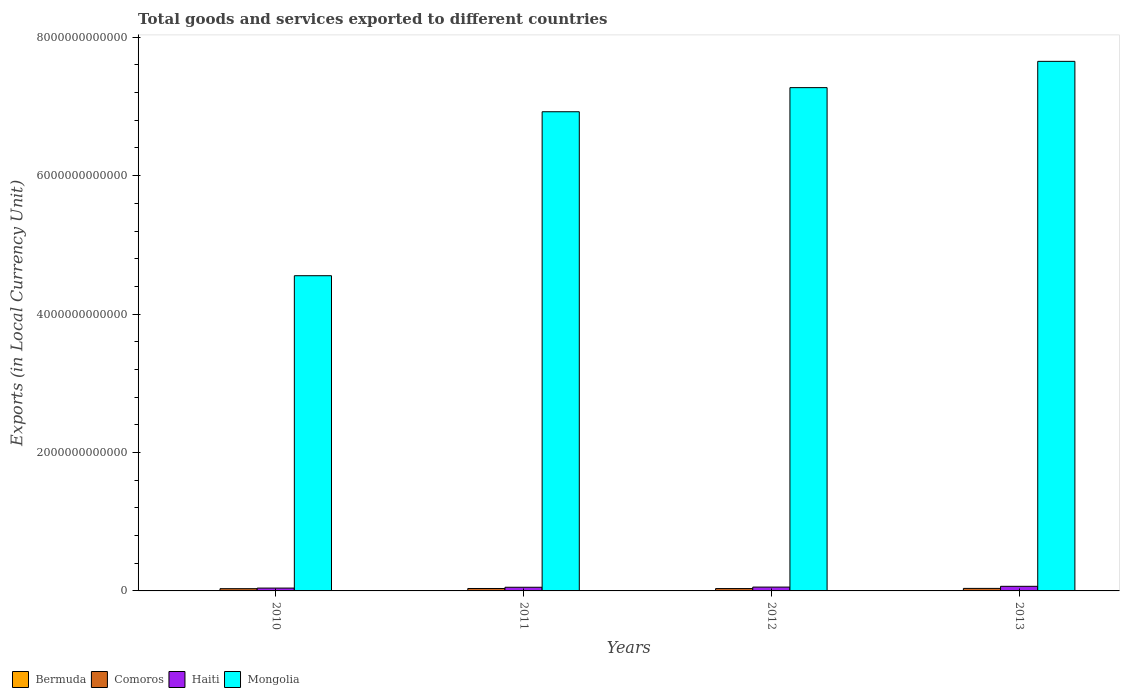How many different coloured bars are there?
Make the answer very short. 4. Are the number of bars per tick equal to the number of legend labels?
Your answer should be very brief. Yes. How many bars are there on the 1st tick from the left?
Ensure brevity in your answer.  4. What is the label of the 3rd group of bars from the left?
Make the answer very short. 2012. In how many cases, is the number of bars for a given year not equal to the number of legend labels?
Give a very brief answer. 0. What is the Amount of goods and services exports in Bermuda in 2012?
Your response must be concise. 2.59e+09. Across all years, what is the maximum Amount of goods and services exports in Comoros?
Your answer should be compact. 3.64e+1. Across all years, what is the minimum Amount of goods and services exports in Mongolia?
Your response must be concise. 4.55e+12. What is the total Amount of goods and services exports in Haiti in the graph?
Your answer should be compact. 2.16e+11. What is the difference between the Amount of goods and services exports in Mongolia in 2010 and that in 2012?
Provide a succinct answer. -2.72e+12. What is the difference between the Amount of goods and services exports in Haiti in 2012 and the Amount of goods and services exports in Comoros in 2013?
Offer a terse response. 1.91e+1. What is the average Amount of goods and services exports in Comoros per year?
Offer a terse response. 3.45e+1. In the year 2010, what is the difference between the Amount of goods and services exports in Haiti and Amount of goods and services exports in Mongolia?
Give a very brief answer. -4.51e+12. What is the ratio of the Amount of goods and services exports in Haiti in 2012 to that in 2013?
Offer a very short reply. 0.83. Is the Amount of goods and services exports in Bermuda in 2011 less than that in 2012?
Provide a short and direct response. No. What is the difference between the highest and the second highest Amount of goods and services exports in Bermuda?
Provide a succinct answer. 4.78e+07. What is the difference between the highest and the lowest Amount of goods and services exports in Mongolia?
Keep it short and to the point. 3.10e+12. Is it the case that in every year, the sum of the Amount of goods and services exports in Bermuda and Amount of goods and services exports in Haiti is greater than the sum of Amount of goods and services exports in Mongolia and Amount of goods and services exports in Comoros?
Provide a succinct answer. No. What does the 3rd bar from the left in 2012 represents?
Ensure brevity in your answer.  Haiti. What does the 1st bar from the right in 2010 represents?
Your response must be concise. Mongolia. How many bars are there?
Ensure brevity in your answer.  16. What is the difference between two consecutive major ticks on the Y-axis?
Your answer should be compact. 2.00e+12. Does the graph contain grids?
Provide a succinct answer. No. Where does the legend appear in the graph?
Your answer should be very brief. Bottom left. How many legend labels are there?
Provide a short and direct response. 4. How are the legend labels stacked?
Ensure brevity in your answer.  Horizontal. What is the title of the graph?
Offer a terse response. Total goods and services exported to different countries. What is the label or title of the X-axis?
Offer a very short reply. Years. What is the label or title of the Y-axis?
Your answer should be very brief. Exports (in Local Currency Unit). What is the Exports (in Local Currency Unit) in Bermuda in 2010?
Your response must be concise. 2.70e+09. What is the Exports (in Local Currency Unit) in Comoros in 2010?
Give a very brief answer. 3.25e+1. What is the Exports (in Local Currency Unit) in Haiti in 2010?
Keep it short and to the point. 4.10e+1. What is the Exports (in Local Currency Unit) in Mongolia in 2010?
Give a very brief answer. 4.55e+12. What is the Exports (in Local Currency Unit) in Bermuda in 2011?
Make the answer very short. 2.64e+09. What is the Exports (in Local Currency Unit) of Comoros in 2011?
Keep it short and to the point. 3.50e+1. What is the Exports (in Local Currency Unit) in Haiti in 2011?
Keep it short and to the point. 5.28e+1. What is the Exports (in Local Currency Unit) in Mongolia in 2011?
Your answer should be very brief. 6.92e+12. What is the Exports (in Local Currency Unit) of Bermuda in 2012?
Offer a terse response. 2.59e+09. What is the Exports (in Local Currency Unit) in Comoros in 2012?
Your answer should be very brief. 3.40e+1. What is the Exports (in Local Currency Unit) of Haiti in 2012?
Provide a short and direct response. 5.55e+1. What is the Exports (in Local Currency Unit) of Mongolia in 2012?
Your answer should be compact. 7.27e+12. What is the Exports (in Local Currency Unit) of Bermuda in 2013?
Your answer should be compact. 2.66e+09. What is the Exports (in Local Currency Unit) in Comoros in 2013?
Your answer should be compact. 3.64e+1. What is the Exports (in Local Currency Unit) in Haiti in 2013?
Give a very brief answer. 6.65e+1. What is the Exports (in Local Currency Unit) of Mongolia in 2013?
Your answer should be very brief. 7.65e+12. Across all years, what is the maximum Exports (in Local Currency Unit) of Bermuda?
Provide a short and direct response. 2.70e+09. Across all years, what is the maximum Exports (in Local Currency Unit) in Comoros?
Your response must be concise. 3.64e+1. Across all years, what is the maximum Exports (in Local Currency Unit) in Haiti?
Provide a succinct answer. 6.65e+1. Across all years, what is the maximum Exports (in Local Currency Unit) in Mongolia?
Your answer should be compact. 7.65e+12. Across all years, what is the minimum Exports (in Local Currency Unit) in Bermuda?
Your response must be concise. 2.59e+09. Across all years, what is the minimum Exports (in Local Currency Unit) in Comoros?
Your answer should be very brief. 3.25e+1. Across all years, what is the minimum Exports (in Local Currency Unit) of Haiti?
Offer a terse response. 4.10e+1. Across all years, what is the minimum Exports (in Local Currency Unit) of Mongolia?
Offer a very short reply. 4.55e+12. What is the total Exports (in Local Currency Unit) in Bermuda in the graph?
Give a very brief answer. 1.06e+1. What is the total Exports (in Local Currency Unit) of Comoros in the graph?
Provide a succinct answer. 1.38e+11. What is the total Exports (in Local Currency Unit) of Haiti in the graph?
Provide a short and direct response. 2.16e+11. What is the total Exports (in Local Currency Unit) of Mongolia in the graph?
Provide a succinct answer. 2.64e+13. What is the difference between the Exports (in Local Currency Unit) of Bermuda in 2010 and that in 2011?
Provide a succinct answer. 6.04e+07. What is the difference between the Exports (in Local Currency Unit) of Comoros in 2010 and that in 2011?
Provide a succinct answer. -2.54e+09. What is the difference between the Exports (in Local Currency Unit) of Haiti in 2010 and that in 2011?
Provide a short and direct response. -1.19e+1. What is the difference between the Exports (in Local Currency Unit) of Mongolia in 2010 and that in 2011?
Provide a short and direct response. -2.37e+12. What is the difference between the Exports (in Local Currency Unit) in Bermuda in 2010 and that in 2012?
Offer a very short reply. 1.15e+08. What is the difference between the Exports (in Local Currency Unit) in Comoros in 2010 and that in 2012?
Your answer should be very brief. -1.56e+09. What is the difference between the Exports (in Local Currency Unit) in Haiti in 2010 and that in 2012?
Make the answer very short. -1.45e+1. What is the difference between the Exports (in Local Currency Unit) in Mongolia in 2010 and that in 2012?
Provide a succinct answer. -2.72e+12. What is the difference between the Exports (in Local Currency Unit) in Bermuda in 2010 and that in 2013?
Offer a very short reply. 4.78e+07. What is the difference between the Exports (in Local Currency Unit) in Comoros in 2010 and that in 2013?
Provide a succinct answer. -3.94e+09. What is the difference between the Exports (in Local Currency Unit) in Haiti in 2010 and that in 2013?
Your answer should be compact. -2.56e+1. What is the difference between the Exports (in Local Currency Unit) of Mongolia in 2010 and that in 2013?
Your response must be concise. -3.10e+12. What is the difference between the Exports (in Local Currency Unit) of Bermuda in 2011 and that in 2012?
Provide a short and direct response. 5.48e+07. What is the difference between the Exports (in Local Currency Unit) of Comoros in 2011 and that in 2012?
Give a very brief answer. 9.85e+08. What is the difference between the Exports (in Local Currency Unit) in Haiti in 2011 and that in 2012?
Your answer should be very brief. -2.62e+09. What is the difference between the Exports (in Local Currency Unit) of Mongolia in 2011 and that in 2012?
Offer a very short reply. -3.48e+11. What is the difference between the Exports (in Local Currency Unit) of Bermuda in 2011 and that in 2013?
Make the answer very short. -1.27e+07. What is the difference between the Exports (in Local Currency Unit) of Comoros in 2011 and that in 2013?
Make the answer very short. -1.39e+09. What is the difference between the Exports (in Local Currency Unit) of Haiti in 2011 and that in 2013?
Keep it short and to the point. -1.37e+1. What is the difference between the Exports (in Local Currency Unit) in Mongolia in 2011 and that in 2013?
Ensure brevity in your answer.  -7.28e+11. What is the difference between the Exports (in Local Currency Unit) of Bermuda in 2012 and that in 2013?
Give a very brief answer. -6.75e+07. What is the difference between the Exports (in Local Currency Unit) of Comoros in 2012 and that in 2013?
Your answer should be compact. -2.38e+09. What is the difference between the Exports (in Local Currency Unit) of Haiti in 2012 and that in 2013?
Your answer should be compact. -1.11e+1. What is the difference between the Exports (in Local Currency Unit) in Mongolia in 2012 and that in 2013?
Your answer should be compact. -3.80e+11. What is the difference between the Exports (in Local Currency Unit) of Bermuda in 2010 and the Exports (in Local Currency Unit) of Comoros in 2011?
Your response must be concise. -3.23e+1. What is the difference between the Exports (in Local Currency Unit) in Bermuda in 2010 and the Exports (in Local Currency Unit) in Haiti in 2011?
Your answer should be very brief. -5.01e+1. What is the difference between the Exports (in Local Currency Unit) in Bermuda in 2010 and the Exports (in Local Currency Unit) in Mongolia in 2011?
Your answer should be compact. -6.92e+12. What is the difference between the Exports (in Local Currency Unit) in Comoros in 2010 and the Exports (in Local Currency Unit) in Haiti in 2011?
Your response must be concise. -2.04e+1. What is the difference between the Exports (in Local Currency Unit) in Comoros in 2010 and the Exports (in Local Currency Unit) in Mongolia in 2011?
Provide a succinct answer. -6.89e+12. What is the difference between the Exports (in Local Currency Unit) of Haiti in 2010 and the Exports (in Local Currency Unit) of Mongolia in 2011?
Offer a very short reply. -6.88e+12. What is the difference between the Exports (in Local Currency Unit) of Bermuda in 2010 and the Exports (in Local Currency Unit) of Comoros in 2012?
Ensure brevity in your answer.  -3.13e+1. What is the difference between the Exports (in Local Currency Unit) in Bermuda in 2010 and the Exports (in Local Currency Unit) in Haiti in 2012?
Provide a short and direct response. -5.28e+1. What is the difference between the Exports (in Local Currency Unit) of Bermuda in 2010 and the Exports (in Local Currency Unit) of Mongolia in 2012?
Your answer should be compact. -7.27e+12. What is the difference between the Exports (in Local Currency Unit) in Comoros in 2010 and the Exports (in Local Currency Unit) in Haiti in 2012?
Ensure brevity in your answer.  -2.30e+1. What is the difference between the Exports (in Local Currency Unit) of Comoros in 2010 and the Exports (in Local Currency Unit) of Mongolia in 2012?
Provide a short and direct response. -7.24e+12. What is the difference between the Exports (in Local Currency Unit) in Haiti in 2010 and the Exports (in Local Currency Unit) in Mongolia in 2012?
Your answer should be very brief. -7.23e+12. What is the difference between the Exports (in Local Currency Unit) in Bermuda in 2010 and the Exports (in Local Currency Unit) in Comoros in 2013?
Provide a short and direct response. -3.37e+1. What is the difference between the Exports (in Local Currency Unit) in Bermuda in 2010 and the Exports (in Local Currency Unit) in Haiti in 2013?
Provide a succinct answer. -6.38e+1. What is the difference between the Exports (in Local Currency Unit) of Bermuda in 2010 and the Exports (in Local Currency Unit) of Mongolia in 2013?
Make the answer very short. -7.65e+12. What is the difference between the Exports (in Local Currency Unit) of Comoros in 2010 and the Exports (in Local Currency Unit) of Haiti in 2013?
Your answer should be very brief. -3.41e+1. What is the difference between the Exports (in Local Currency Unit) of Comoros in 2010 and the Exports (in Local Currency Unit) of Mongolia in 2013?
Ensure brevity in your answer.  -7.62e+12. What is the difference between the Exports (in Local Currency Unit) in Haiti in 2010 and the Exports (in Local Currency Unit) in Mongolia in 2013?
Offer a terse response. -7.61e+12. What is the difference between the Exports (in Local Currency Unit) in Bermuda in 2011 and the Exports (in Local Currency Unit) in Comoros in 2012?
Give a very brief answer. -3.14e+1. What is the difference between the Exports (in Local Currency Unit) of Bermuda in 2011 and the Exports (in Local Currency Unit) of Haiti in 2012?
Ensure brevity in your answer.  -5.28e+1. What is the difference between the Exports (in Local Currency Unit) of Bermuda in 2011 and the Exports (in Local Currency Unit) of Mongolia in 2012?
Keep it short and to the point. -7.27e+12. What is the difference between the Exports (in Local Currency Unit) in Comoros in 2011 and the Exports (in Local Currency Unit) in Haiti in 2012?
Your answer should be compact. -2.04e+1. What is the difference between the Exports (in Local Currency Unit) of Comoros in 2011 and the Exports (in Local Currency Unit) of Mongolia in 2012?
Offer a very short reply. -7.24e+12. What is the difference between the Exports (in Local Currency Unit) in Haiti in 2011 and the Exports (in Local Currency Unit) in Mongolia in 2012?
Ensure brevity in your answer.  -7.22e+12. What is the difference between the Exports (in Local Currency Unit) of Bermuda in 2011 and the Exports (in Local Currency Unit) of Comoros in 2013?
Keep it short and to the point. -3.38e+1. What is the difference between the Exports (in Local Currency Unit) in Bermuda in 2011 and the Exports (in Local Currency Unit) in Haiti in 2013?
Keep it short and to the point. -6.39e+1. What is the difference between the Exports (in Local Currency Unit) in Bermuda in 2011 and the Exports (in Local Currency Unit) in Mongolia in 2013?
Ensure brevity in your answer.  -7.65e+12. What is the difference between the Exports (in Local Currency Unit) of Comoros in 2011 and the Exports (in Local Currency Unit) of Haiti in 2013?
Provide a succinct answer. -3.15e+1. What is the difference between the Exports (in Local Currency Unit) in Comoros in 2011 and the Exports (in Local Currency Unit) in Mongolia in 2013?
Provide a succinct answer. -7.62e+12. What is the difference between the Exports (in Local Currency Unit) of Haiti in 2011 and the Exports (in Local Currency Unit) of Mongolia in 2013?
Make the answer very short. -7.60e+12. What is the difference between the Exports (in Local Currency Unit) in Bermuda in 2012 and the Exports (in Local Currency Unit) in Comoros in 2013?
Keep it short and to the point. -3.38e+1. What is the difference between the Exports (in Local Currency Unit) in Bermuda in 2012 and the Exports (in Local Currency Unit) in Haiti in 2013?
Keep it short and to the point. -6.40e+1. What is the difference between the Exports (in Local Currency Unit) in Bermuda in 2012 and the Exports (in Local Currency Unit) in Mongolia in 2013?
Your answer should be very brief. -7.65e+12. What is the difference between the Exports (in Local Currency Unit) of Comoros in 2012 and the Exports (in Local Currency Unit) of Haiti in 2013?
Ensure brevity in your answer.  -3.25e+1. What is the difference between the Exports (in Local Currency Unit) of Comoros in 2012 and the Exports (in Local Currency Unit) of Mongolia in 2013?
Keep it short and to the point. -7.62e+12. What is the difference between the Exports (in Local Currency Unit) in Haiti in 2012 and the Exports (in Local Currency Unit) in Mongolia in 2013?
Provide a succinct answer. -7.60e+12. What is the average Exports (in Local Currency Unit) in Bermuda per year?
Your response must be concise. 2.65e+09. What is the average Exports (in Local Currency Unit) of Comoros per year?
Your answer should be very brief. 3.45e+1. What is the average Exports (in Local Currency Unit) of Haiti per year?
Your answer should be compact. 5.40e+1. What is the average Exports (in Local Currency Unit) in Mongolia per year?
Offer a very short reply. 6.60e+12. In the year 2010, what is the difference between the Exports (in Local Currency Unit) of Bermuda and Exports (in Local Currency Unit) of Comoros?
Provide a succinct answer. -2.98e+1. In the year 2010, what is the difference between the Exports (in Local Currency Unit) of Bermuda and Exports (in Local Currency Unit) of Haiti?
Offer a terse response. -3.83e+1. In the year 2010, what is the difference between the Exports (in Local Currency Unit) of Bermuda and Exports (in Local Currency Unit) of Mongolia?
Make the answer very short. -4.55e+12. In the year 2010, what is the difference between the Exports (in Local Currency Unit) of Comoros and Exports (in Local Currency Unit) of Haiti?
Keep it short and to the point. -8.48e+09. In the year 2010, what is the difference between the Exports (in Local Currency Unit) of Comoros and Exports (in Local Currency Unit) of Mongolia?
Offer a very short reply. -4.52e+12. In the year 2010, what is the difference between the Exports (in Local Currency Unit) of Haiti and Exports (in Local Currency Unit) of Mongolia?
Make the answer very short. -4.51e+12. In the year 2011, what is the difference between the Exports (in Local Currency Unit) of Bermuda and Exports (in Local Currency Unit) of Comoros?
Ensure brevity in your answer.  -3.24e+1. In the year 2011, what is the difference between the Exports (in Local Currency Unit) in Bermuda and Exports (in Local Currency Unit) in Haiti?
Offer a terse response. -5.02e+1. In the year 2011, what is the difference between the Exports (in Local Currency Unit) in Bermuda and Exports (in Local Currency Unit) in Mongolia?
Give a very brief answer. -6.92e+12. In the year 2011, what is the difference between the Exports (in Local Currency Unit) in Comoros and Exports (in Local Currency Unit) in Haiti?
Your response must be concise. -1.78e+1. In the year 2011, what is the difference between the Exports (in Local Currency Unit) of Comoros and Exports (in Local Currency Unit) of Mongolia?
Offer a terse response. -6.89e+12. In the year 2011, what is the difference between the Exports (in Local Currency Unit) in Haiti and Exports (in Local Currency Unit) in Mongolia?
Your answer should be very brief. -6.87e+12. In the year 2012, what is the difference between the Exports (in Local Currency Unit) of Bermuda and Exports (in Local Currency Unit) of Comoros?
Provide a succinct answer. -3.14e+1. In the year 2012, what is the difference between the Exports (in Local Currency Unit) of Bermuda and Exports (in Local Currency Unit) of Haiti?
Provide a short and direct response. -5.29e+1. In the year 2012, what is the difference between the Exports (in Local Currency Unit) in Bermuda and Exports (in Local Currency Unit) in Mongolia?
Offer a terse response. -7.27e+12. In the year 2012, what is the difference between the Exports (in Local Currency Unit) of Comoros and Exports (in Local Currency Unit) of Haiti?
Your response must be concise. -2.14e+1. In the year 2012, what is the difference between the Exports (in Local Currency Unit) of Comoros and Exports (in Local Currency Unit) of Mongolia?
Offer a very short reply. -7.24e+12. In the year 2012, what is the difference between the Exports (in Local Currency Unit) of Haiti and Exports (in Local Currency Unit) of Mongolia?
Give a very brief answer. -7.22e+12. In the year 2013, what is the difference between the Exports (in Local Currency Unit) of Bermuda and Exports (in Local Currency Unit) of Comoros?
Ensure brevity in your answer.  -3.38e+1. In the year 2013, what is the difference between the Exports (in Local Currency Unit) in Bermuda and Exports (in Local Currency Unit) in Haiti?
Your answer should be very brief. -6.39e+1. In the year 2013, what is the difference between the Exports (in Local Currency Unit) in Bermuda and Exports (in Local Currency Unit) in Mongolia?
Offer a terse response. -7.65e+12. In the year 2013, what is the difference between the Exports (in Local Currency Unit) of Comoros and Exports (in Local Currency Unit) of Haiti?
Offer a very short reply. -3.01e+1. In the year 2013, what is the difference between the Exports (in Local Currency Unit) in Comoros and Exports (in Local Currency Unit) in Mongolia?
Offer a terse response. -7.61e+12. In the year 2013, what is the difference between the Exports (in Local Currency Unit) in Haiti and Exports (in Local Currency Unit) in Mongolia?
Offer a very short reply. -7.58e+12. What is the ratio of the Exports (in Local Currency Unit) of Bermuda in 2010 to that in 2011?
Offer a terse response. 1.02. What is the ratio of the Exports (in Local Currency Unit) in Comoros in 2010 to that in 2011?
Ensure brevity in your answer.  0.93. What is the ratio of the Exports (in Local Currency Unit) of Haiti in 2010 to that in 2011?
Offer a terse response. 0.78. What is the ratio of the Exports (in Local Currency Unit) in Mongolia in 2010 to that in 2011?
Your answer should be very brief. 0.66. What is the ratio of the Exports (in Local Currency Unit) in Bermuda in 2010 to that in 2012?
Your answer should be compact. 1.04. What is the ratio of the Exports (in Local Currency Unit) of Comoros in 2010 to that in 2012?
Your answer should be very brief. 0.95. What is the ratio of the Exports (in Local Currency Unit) in Haiti in 2010 to that in 2012?
Provide a succinct answer. 0.74. What is the ratio of the Exports (in Local Currency Unit) in Mongolia in 2010 to that in 2012?
Your answer should be very brief. 0.63. What is the ratio of the Exports (in Local Currency Unit) of Comoros in 2010 to that in 2013?
Ensure brevity in your answer.  0.89. What is the ratio of the Exports (in Local Currency Unit) in Haiti in 2010 to that in 2013?
Give a very brief answer. 0.62. What is the ratio of the Exports (in Local Currency Unit) of Mongolia in 2010 to that in 2013?
Provide a succinct answer. 0.6. What is the ratio of the Exports (in Local Currency Unit) of Bermuda in 2011 to that in 2012?
Give a very brief answer. 1.02. What is the ratio of the Exports (in Local Currency Unit) in Comoros in 2011 to that in 2012?
Make the answer very short. 1.03. What is the ratio of the Exports (in Local Currency Unit) of Haiti in 2011 to that in 2012?
Your answer should be very brief. 0.95. What is the ratio of the Exports (in Local Currency Unit) of Mongolia in 2011 to that in 2012?
Keep it short and to the point. 0.95. What is the ratio of the Exports (in Local Currency Unit) in Comoros in 2011 to that in 2013?
Offer a very short reply. 0.96. What is the ratio of the Exports (in Local Currency Unit) of Haiti in 2011 to that in 2013?
Your response must be concise. 0.79. What is the ratio of the Exports (in Local Currency Unit) of Mongolia in 2011 to that in 2013?
Keep it short and to the point. 0.9. What is the ratio of the Exports (in Local Currency Unit) of Bermuda in 2012 to that in 2013?
Keep it short and to the point. 0.97. What is the ratio of the Exports (in Local Currency Unit) of Comoros in 2012 to that in 2013?
Ensure brevity in your answer.  0.93. What is the ratio of the Exports (in Local Currency Unit) in Haiti in 2012 to that in 2013?
Provide a succinct answer. 0.83. What is the ratio of the Exports (in Local Currency Unit) of Mongolia in 2012 to that in 2013?
Provide a short and direct response. 0.95. What is the difference between the highest and the second highest Exports (in Local Currency Unit) in Bermuda?
Offer a very short reply. 4.78e+07. What is the difference between the highest and the second highest Exports (in Local Currency Unit) of Comoros?
Provide a short and direct response. 1.39e+09. What is the difference between the highest and the second highest Exports (in Local Currency Unit) of Haiti?
Your answer should be very brief. 1.11e+1. What is the difference between the highest and the second highest Exports (in Local Currency Unit) in Mongolia?
Provide a succinct answer. 3.80e+11. What is the difference between the highest and the lowest Exports (in Local Currency Unit) in Bermuda?
Keep it short and to the point. 1.15e+08. What is the difference between the highest and the lowest Exports (in Local Currency Unit) of Comoros?
Your answer should be very brief. 3.94e+09. What is the difference between the highest and the lowest Exports (in Local Currency Unit) of Haiti?
Your answer should be very brief. 2.56e+1. What is the difference between the highest and the lowest Exports (in Local Currency Unit) in Mongolia?
Your answer should be very brief. 3.10e+12. 